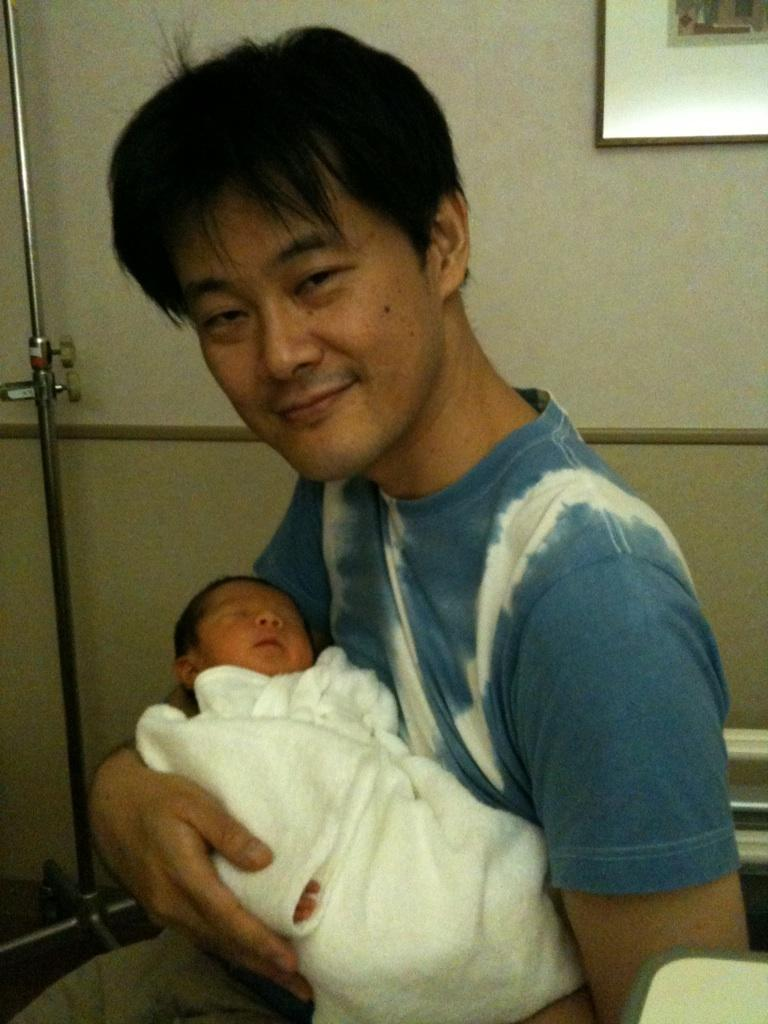What is the person in the image doing? The person is holding a baby. What can be seen in the background of the image? There is a wall with a photo frame in the background. What object is present in the image besides the person and the baby? There is a stand in the image. What type of arithmetic problem is the baby solving in the image? There is no arithmetic problem present in the image; it features a person holding a baby and a stand in the background. 